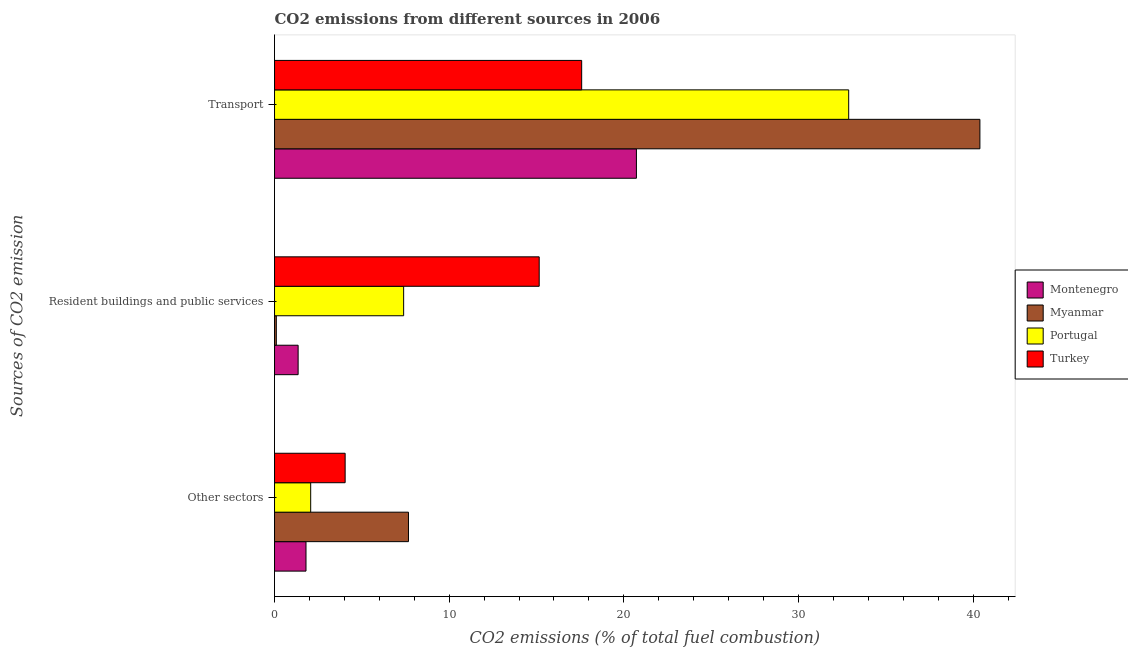How many groups of bars are there?
Provide a short and direct response. 3. Are the number of bars on each tick of the Y-axis equal?
Give a very brief answer. Yes. How many bars are there on the 1st tick from the bottom?
Offer a very short reply. 4. What is the label of the 2nd group of bars from the top?
Your answer should be compact. Resident buildings and public services. What is the percentage of co2 emissions from other sectors in Portugal?
Keep it short and to the point. 2.07. Across all countries, what is the maximum percentage of co2 emissions from other sectors?
Ensure brevity in your answer.  7.67. Across all countries, what is the minimum percentage of co2 emissions from resident buildings and public services?
Keep it short and to the point. 0.1. In which country was the percentage of co2 emissions from transport minimum?
Provide a short and direct response. Turkey. What is the total percentage of co2 emissions from transport in the graph?
Provide a succinct answer. 111.57. What is the difference between the percentage of co2 emissions from resident buildings and public services in Myanmar and that in Portugal?
Offer a terse response. -7.29. What is the difference between the percentage of co2 emissions from resident buildings and public services in Montenegro and the percentage of co2 emissions from other sectors in Turkey?
Offer a terse response. -2.69. What is the average percentage of co2 emissions from transport per country?
Make the answer very short. 27.89. What is the difference between the percentage of co2 emissions from other sectors and percentage of co2 emissions from resident buildings and public services in Portugal?
Keep it short and to the point. -5.32. What is the ratio of the percentage of co2 emissions from resident buildings and public services in Portugal to that in Montenegro?
Give a very brief answer. 5.47. What is the difference between the highest and the second highest percentage of co2 emissions from resident buildings and public services?
Your response must be concise. 7.76. What is the difference between the highest and the lowest percentage of co2 emissions from other sectors?
Your answer should be very brief. 5.87. In how many countries, is the percentage of co2 emissions from transport greater than the average percentage of co2 emissions from transport taken over all countries?
Your answer should be very brief. 2. What does the 3rd bar from the top in Other sectors represents?
Keep it short and to the point. Myanmar. What does the 1st bar from the bottom in Other sectors represents?
Your answer should be compact. Montenegro. Is it the case that in every country, the sum of the percentage of co2 emissions from other sectors and percentage of co2 emissions from resident buildings and public services is greater than the percentage of co2 emissions from transport?
Provide a succinct answer. No. How many bars are there?
Your response must be concise. 12. How many countries are there in the graph?
Make the answer very short. 4. Are the values on the major ticks of X-axis written in scientific E-notation?
Provide a succinct answer. No. Does the graph contain any zero values?
Keep it short and to the point. No. How many legend labels are there?
Your answer should be compact. 4. What is the title of the graph?
Your answer should be compact. CO2 emissions from different sources in 2006. What is the label or title of the X-axis?
Give a very brief answer. CO2 emissions (% of total fuel combustion). What is the label or title of the Y-axis?
Provide a succinct answer. Sources of CO2 emission. What is the CO2 emissions (% of total fuel combustion) in Montenegro in Other sectors?
Ensure brevity in your answer.  1.8. What is the CO2 emissions (% of total fuel combustion) in Myanmar in Other sectors?
Keep it short and to the point. 7.67. What is the CO2 emissions (% of total fuel combustion) in Portugal in Other sectors?
Ensure brevity in your answer.  2.07. What is the CO2 emissions (% of total fuel combustion) in Turkey in Other sectors?
Your answer should be very brief. 4.04. What is the CO2 emissions (% of total fuel combustion) of Montenegro in Resident buildings and public services?
Your answer should be very brief. 1.35. What is the CO2 emissions (% of total fuel combustion) of Myanmar in Resident buildings and public services?
Offer a very short reply. 0.1. What is the CO2 emissions (% of total fuel combustion) in Portugal in Resident buildings and public services?
Give a very brief answer. 7.39. What is the CO2 emissions (% of total fuel combustion) of Turkey in Resident buildings and public services?
Ensure brevity in your answer.  15.15. What is the CO2 emissions (% of total fuel combustion) of Montenegro in Transport?
Your answer should be compact. 20.72. What is the CO2 emissions (% of total fuel combustion) of Myanmar in Transport?
Offer a very short reply. 40.39. What is the CO2 emissions (% of total fuel combustion) in Portugal in Transport?
Offer a very short reply. 32.88. What is the CO2 emissions (% of total fuel combustion) in Turkey in Transport?
Your answer should be compact. 17.59. Across all Sources of CO2 emission, what is the maximum CO2 emissions (% of total fuel combustion) of Montenegro?
Ensure brevity in your answer.  20.72. Across all Sources of CO2 emission, what is the maximum CO2 emissions (% of total fuel combustion) of Myanmar?
Provide a succinct answer. 40.39. Across all Sources of CO2 emission, what is the maximum CO2 emissions (% of total fuel combustion) of Portugal?
Provide a short and direct response. 32.88. Across all Sources of CO2 emission, what is the maximum CO2 emissions (% of total fuel combustion) of Turkey?
Offer a terse response. 17.59. Across all Sources of CO2 emission, what is the minimum CO2 emissions (% of total fuel combustion) of Montenegro?
Make the answer very short. 1.35. Across all Sources of CO2 emission, what is the minimum CO2 emissions (% of total fuel combustion) in Myanmar?
Keep it short and to the point. 0.1. Across all Sources of CO2 emission, what is the minimum CO2 emissions (% of total fuel combustion) in Portugal?
Provide a short and direct response. 2.07. Across all Sources of CO2 emission, what is the minimum CO2 emissions (% of total fuel combustion) in Turkey?
Your answer should be very brief. 4.04. What is the total CO2 emissions (% of total fuel combustion) in Montenegro in the graph?
Offer a terse response. 23.87. What is the total CO2 emissions (% of total fuel combustion) of Myanmar in the graph?
Your response must be concise. 48.16. What is the total CO2 emissions (% of total fuel combustion) of Portugal in the graph?
Your answer should be very brief. 42.34. What is the total CO2 emissions (% of total fuel combustion) in Turkey in the graph?
Keep it short and to the point. 36.78. What is the difference between the CO2 emissions (% of total fuel combustion) in Montenegro in Other sectors and that in Resident buildings and public services?
Provide a succinct answer. 0.45. What is the difference between the CO2 emissions (% of total fuel combustion) of Myanmar in Other sectors and that in Resident buildings and public services?
Your answer should be very brief. 7.57. What is the difference between the CO2 emissions (% of total fuel combustion) of Portugal in Other sectors and that in Resident buildings and public services?
Offer a terse response. -5.32. What is the difference between the CO2 emissions (% of total fuel combustion) of Turkey in Other sectors and that in Resident buildings and public services?
Give a very brief answer. -11.11. What is the difference between the CO2 emissions (% of total fuel combustion) in Montenegro in Other sectors and that in Transport?
Offer a terse response. -18.92. What is the difference between the CO2 emissions (% of total fuel combustion) of Myanmar in Other sectors and that in Transport?
Your answer should be very brief. -32.72. What is the difference between the CO2 emissions (% of total fuel combustion) in Portugal in Other sectors and that in Transport?
Offer a terse response. -30.81. What is the difference between the CO2 emissions (% of total fuel combustion) of Turkey in Other sectors and that in Transport?
Make the answer very short. -13.54. What is the difference between the CO2 emissions (% of total fuel combustion) of Montenegro in Resident buildings and public services and that in Transport?
Your answer should be very brief. -19.37. What is the difference between the CO2 emissions (% of total fuel combustion) of Myanmar in Resident buildings and public services and that in Transport?
Your answer should be very brief. -40.29. What is the difference between the CO2 emissions (% of total fuel combustion) in Portugal in Resident buildings and public services and that in Transport?
Your response must be concise. -25.48. What is the difference between the CO2 emissions (% of total fuel combustion) of Turkey in Resident buildings and public services and that in Transport?
Make the answer very short. -2.43. What is the difference between the CO2 emissions (% of total fuel combustion) of Montenegro in Other sectors and the CO2 emissions (% of total fuel combustion) of Myanmar in Resident buildings and public services?
Provide a succinct answer. 1.7. What is the difference between the CO2 emissions (% of total fuel combustion) of Montenegro in Other sectors and the CO2 emissions (% of total fuel combustion) of Portugal in Resident buildings and public services?
Your answer should be compact. -5.59. What is the difference between the CO2 emissions (% of total fuel combustion) in Montenegro in Other sectors and the CO2 emissions (% of total fuel combustion) in Turkey in Resident buildings and public services?
Your response must be concise. -13.35. What is the difference between the CO2 emissions (% of total fuel combustion) of Myanmar in Other sectors and the CO2 emissions (% of total fuel combustion) of Portugal in Resident buildings and public services?
Give a very brief answer. 0.28. What is the difference between the CO2 emissions (% of total fuel combustion) in Myanmar in Other sectors and the CO2 emissions (% of total fuel combustion) in Turkey in Resident buildings and public services?
Ensure brevity in your answer.  -7.49. What is the difference between the CO2 emissions (% of total fuel combustion) in Portugal in Other sectors and the CO2 emissions (% of total fuel combustion) in Turkey in Resident buildings and public services?
Give a very brief answer. -13.08. What is the difference between the CO2 emissions (% of total fuel combustion) of Montenegro in Other sectors and the CO2 emissions (% of total fuel combustion) of Myanmar in Transport?
Provide a short and direct response. -38.59. What is the difference between the CO2 emissions (% of total fuel combustion) in Montenegro in Other sectors and the CO2 emissions (% of total fuel combustion) in Portugal in Transport?
Make the answer very short. -31.07. What is the difference between the CO2 emissions (% of total fuel combustion) in Montenegro in Other sectors and the CO2 emissions (% of total fuel combustion) in Turkey in Transport?
Give a very brief answer. -15.78. What is the difference between the CO2 emissions (% of total fuel combustion) of Myanmar in Other sectors and the CO2 emissions (% of total fuel combustion) of Portugal in Transport?
Your answer should be compact. -25.21. What is the difference between the CO2 emissions (% of total fuel combustion) in Myanmar in Other sectors and the CO2 emissions (% of total fuel combustion) in Turkey in Transport?
Provide a short and direct response. -9.92. What is the difference between the CO2 emissions (% of total fuel combustion) of Portugal in Other sectors and the CO2 emissions (% of total fuel combustion) of Turkey in Transport?
Keep it short and to the point. -15.52. What is the difference between the CO2 emissions (% of total fuel combustion) of Montenegro in Resident buildings and public services and the CO2 emissions (% of total fuel combustion) of Myanmar in Transport?
Provide a short and direct response. -39.04. What is the difference between the CO2 emissions (% of total fuel combustion) of Montenegro in Resident buildings and public services and the CO2 emissions (% of total fuel combustion) of Portugal in Transport?
Your answer should be compact. -31.52. What is the difference between the CO2 emissions (% of total fuel combustion) of Montenegro in Resident buildings and public services and the CO2 emissions (% of total fuel combustion) of Turkey in Transport?
Ensure brevity in your answer.  -16.24. What is the difference between the CO2 emissions (% of total fuel combustion) in Myanmar in Resident buildings and public services and the CO2 emissions (% of total fuel combustion) in Portugal in Transport?
Keep it short and to the point. -32.77. What is the difference between the CO2 emissions (% of total fuel combustion) of Myanmar in Resident buildings and public services and the CO2 emissions (% of total fuel combustion) of Turkey in Transport?
Ensure brevity in your answer.  -17.48. What is the difference between the CO2 emissions (% of total fuel combustion) in Portugal in Resident buildings and public services and the CO2 emissions (% of total fuel combustion) in Turkey in Transport?
Your answer should be very brief. -10.19. What is the average CO2 emissions (% of total fuel combustion) of Montenegro per Sources of CO2 emission?
Keep it short and to the point. 7.96. What is the average CO2 emissions (% of total fuel combustion) of Myanmar per Sources of CO2 emission?
Keep it short and to the point. 16.05. What is the average CO2 emissions (% of total fuel combustion) of Portugal per Sources of CO2 emission?
Give a very brief answer. 14.11. What is the average CO2 emissions (% of total fuel combustion) in Turkey per Sources of CO2 emission?
Keep it short and to the point. 12.26. What is the difference between the CO2 emissions (% of total fuel combustion) in Montenegro and CO2 emissions (% of total fuel combustion) in Myanmar in Other sectors?
Your answer should be very brief. -5.87. What is the difference between the CO2 emissions (% of total fuel combustion) in Montenegro and CO2 emissions (% of total fuel combustion) in Portugal in Other sectors?
Ensure brevity in your answer.  -0.27. What is the difference between the CO2 emissions (% of total fuel combustion) in Montenegro and CO2 emissions (% of total fuel combustion) in Turkey in Other sectors?
Your answer should be very brief. -2.24. What is the difference between the CO2 emissions (% of total fuel combustion) in Myanmar and CO2 emissions (% of total fuel combustion) in Portugal in Other sectors?
Give a very brief answer. 5.6. What is the difference between the CO2 emissions (% of total fuel combustion) in Myanmar and CO2 emissions (% of total fuel combustion) in Turkey in Other sectors?
Ensure brevity in your answer.  3.63. What is the difference between the CO2 emissions (% of total fuel combustion) in Portugal and CO2 emissions (% of total fuel combustion) in Turkey in Other sectors?
Offer a very short reply. -1.97. What is the difference between the CO2 emissions (% of total fuel combustion) of Montenegro and CO2 emissions (% of total fuel combustion) of Myanmar in Resident buildings and public services?
Make the answer very short. 1.25. What is the difference between the CO2 emissions (% of total fuel combustion) in Montenegro and CO2 emissions (% of total fuel combustion) in Portugal in Resident buildings and public services?
Give a very brief answer. -6.04. What is the difference between the CO2 emissions (% of total fuel combustion) of Montenegro and CO2 emissions (% of total fuel combustion) of Turkey in Resident buildings and public services?
Your response must be concise. -13.8. What is the difference between the CO2 emissions (% of total fuel combustion) of Myanmar and CO2 emissions (% of total fuel combustion) of Portugal in Resident buildings and public services?
Keep it short and to the point. -7.29. What is the difference between the CO2 emissions (% of total fuel combustion) of Myanmar and CO2 emissions (% of total fuel combustion) of Turkey in Resident buildings and public services?
Your response must be concise. -15.05. What is the difference between the CO2 emissions (% of total fuel combustion) of Portugal and CO2 emissions (% of total fuel combustion) of Turkey in Resident buildings and public services?
Your response must be concise. -7.76. What is the difference between the CO2 emissions (% of total fuel combustion) of Montenegro and CO2 emissions (% of total fuel combustion) of Myanmar in Transport?
Offer a terse response. -19.67. What is the difference between the CO2 emissions (% of total fuel combustion) of Montenegro and CO2 emissions (% of total fuel combustion) of Portugal in Transport?
Provide a short and direct response. -12.15. What is the difference between the CO2 emissions (% of total fuel combustion) in Montenegro and CO2 emissions (% of total fuel combustion) in Turkey in Transport?
Make the answer very short. 3.13. What is the difference between the CO2 emissions (% of total fuel combustion) of Myanmar and CO2 emissions (% of total fuel combustion) of Portugal in Transport?
Your answer should be very brief. 7.51. What is the difference between the CO2 emissions (% of total fuel combustion) in Myanmar and CO2 emissions (% of total fuel combustion) in Turkey in Transport?
Keep it short and to the point. 22.8. What is the difference between the CO2 emissions (% of total fuel combustion) of Portugal and CO2 emissions (% of total fuel combustion) of Turkey in Transport?
Provide a succinct answer. 15.29. What is the ratio of the CO2 emissions (% of total fuel combustion) of Myanmar in Other sectors to that in Resident buildings and public services?
Your response must be concise. 75. What is the ratio of the CO2 emissions (% of total fuel combustion) of Portugal in Other sectors to that in Resident buildings and public services?
Your answer should be compact. 0.28. What is the ratio of the CO2 emissions (% of total fuel combustion) of Turkey in Other sectors to that in Resident buildings and public services?
Your answer should be very brief. 0.27. What is the ratio of the CO2 emissions (% of total fuel combustion) of Montenegro in Other sectors to that in Transport?
Your answer should be very brief. 0.09. What is the ratio of the CO2 emissions (% of total fuel combustion) of Myanmar in Other sectors to that in Transport?
Your response must be concise. 0.19. What is the ratio of the CO2 emissions (% of total fuel combustion) in Portugal in Other sectors to that in Transport?
Provide a short and direct response. 0.06. What is the ratio of the CO2 emissions (% of total fuel combustion) in Turkey in Other sectors to that in Transport?
Ensure brevity in your answer.  0.23. What is the ratio of the CO2 emissions (% of total fuel combustion) in Montenegro in Resident buildings and public services to that in Transport?
Keep it short and to the point. 0.07. What is the ratio of the CO2 emissions (% of total fuel combustion) in Myanmar in Resident buildings and public services to that in Transport?
Ensure brevity in your answer.  0. What is the ratio of the CO2 emissions (% of total fuel combustion) of Portugal in Resident buildings and public services to that in Transport?
Offer a terse response. 0.22. What is the ratio of the CO2 emissions (% of total fuel combustion) of Turkey in Resident buildings and public services to that in Transport?
Offer a very short reply. 0.86. What is the difference between the highest and the second highest CO2 emissions (% of total fuel combustion) of Montenegro?
Ensure brevity in your answer.  18.92. What is the difference between the highest and the second highest CO2 emissions (% of total fuel combustion) of Myanmar?
Ensure brevity in your answer.  32.72. What is the difference between the highest and the second highest CO2 emissions (% of total fuel combustion) in Portugal?
Provide a short and direct response. 25.48. What is the difference between the highest and the second highest CO2 emissions (% of total fuel combustion) in Turkey?
Provide a short and direct response. 2.43. What is the difference between the highest and the lowest CO2 emissions (% of total fuel combustion) of Montenegro?
Give a very brief answer. 19.37. What is the difference between the highest and the lowest CO2 emissions (% of total fuel combustion) of Myanmar?
Ensure brevity in your answer.  40.29. What is the difference between the highest and the lowest CO2 emissions (% of total fuel combustion) of Portugal?
Provide a succinct answer. 30.81. What is the difference between the highest and the lowest CO2 emissions (% of total fuel combustion) in Turkey?
Provide a succinct answer. 13.54. 